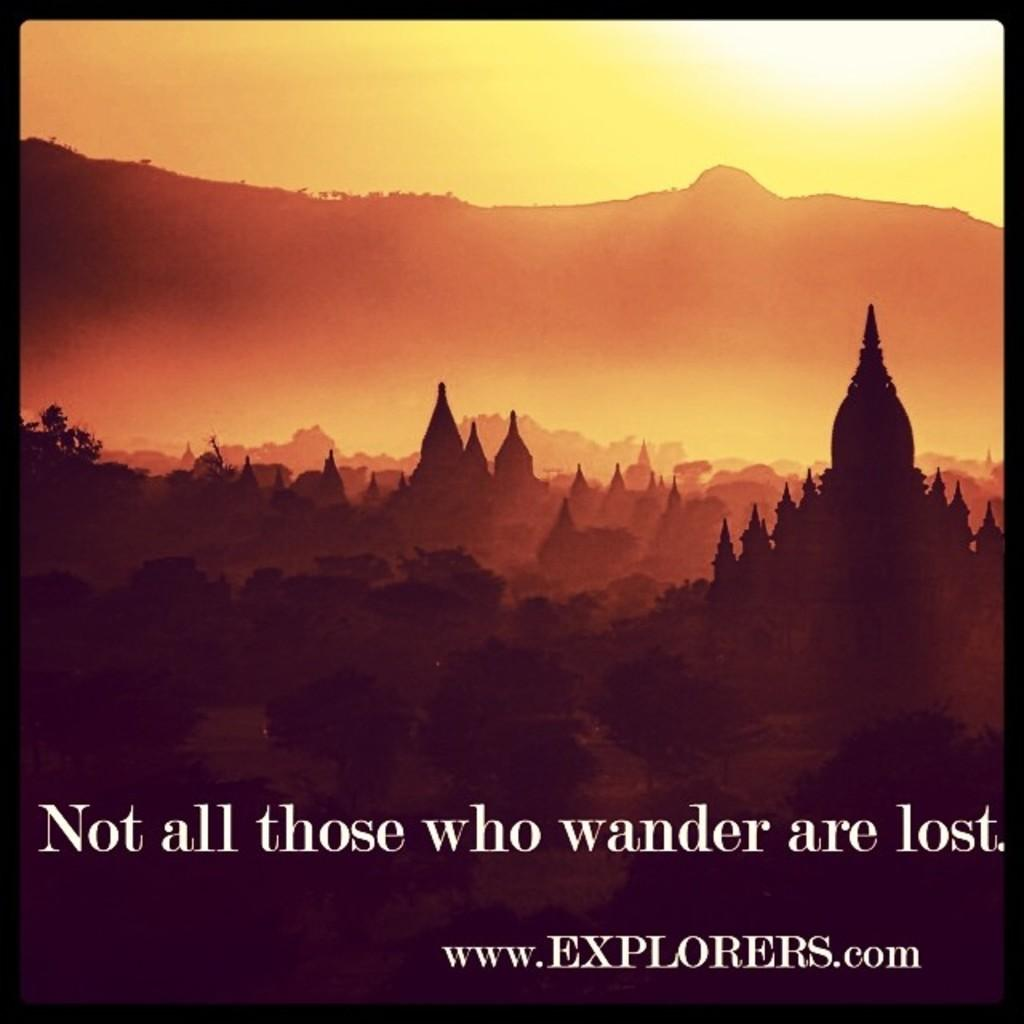Provide a one-sentence caption for the provided image. An explorers.com scenic poster stating "not all those who wander are lost.". 